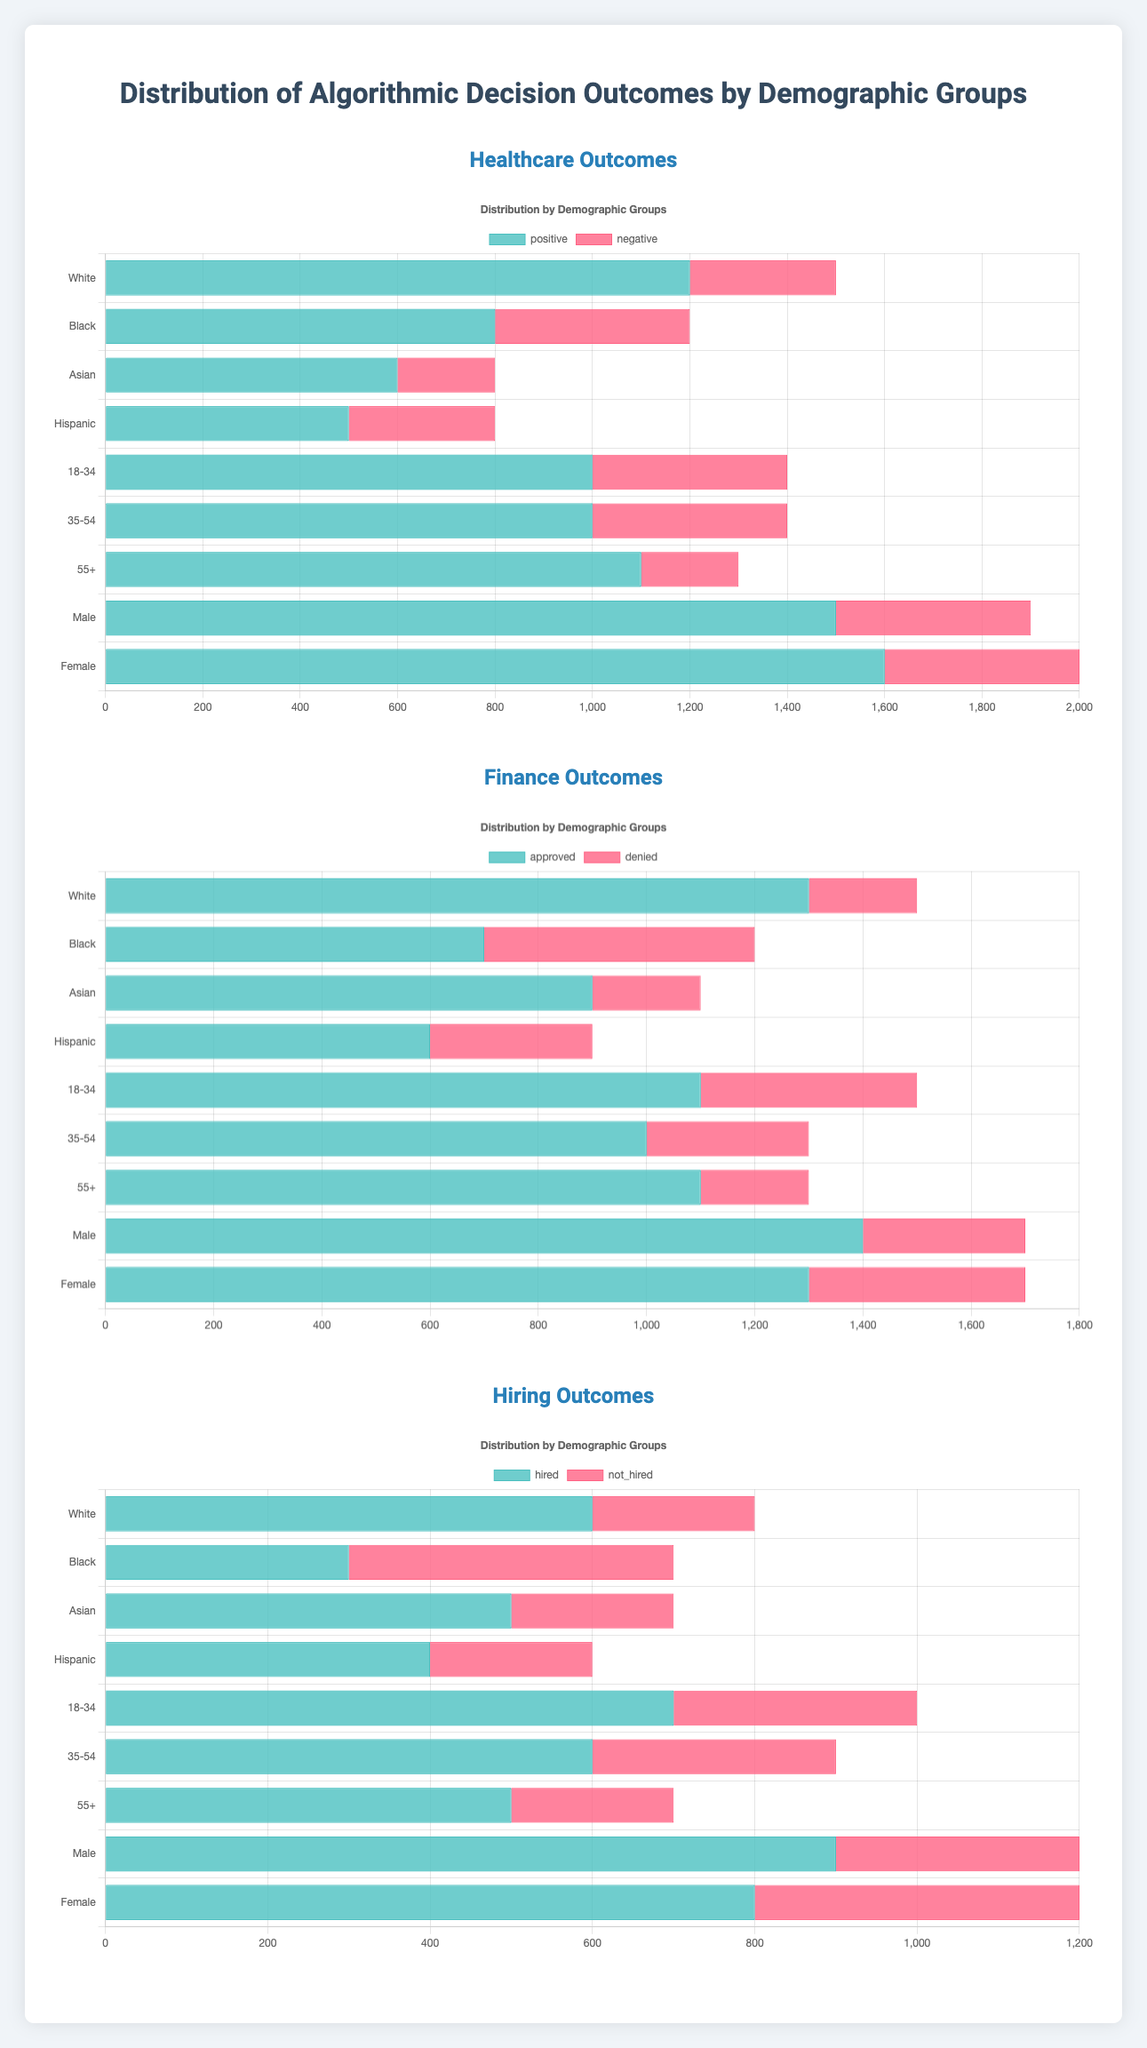How many more positive healthcare outcomes did White participants receive compared to Hispanic participants? First, locate the positive outcomes for both groups in the healthcare section of the chart. White participants received 1200 positive outcomes, while Hispanic participants received 500. The difference is 1200 - 500 = 700.
Answer: 700 Which gender had more negative outcomes in the finance sector? Review the negative outcomes for each gender in the finance section. Males have 300 negative outcomes, and Females have 400. Females had more negative outcomes.
Answer: Female Is the number of positive outcomes for healthcare gender groups higher than the number of positive outcomes for healthcare age groups? Sum the positive outcomes for the gender groups: Male (1500) + Female (1600) = 3100. Then sum the positive outcomes for age groups: 18-34 (1000) + 35-54 (1000) + 55+ (1100) = 3100. Both groups have the same number of positive outcomes.
Answer: No What is the combined number of approved finance outcomes for Asian and Hispanic groups? Add the approved outcomes for Asian and Hispanic groups: Asian (900) + Hispanic (600) = 1500.
Answer: 1500 Which age group has the smallest difference between positive and negative healthcare outcomes? Calculate the difference for each age group: 18-34 has 1000 - 400 = 600, 35-54 has 1000 - 400 = 600, 55+ has 1100 - 200 = 900. Both 18-34 and 35-54 age groups have the smallest difference of 600.
Answer: 18-34 and 35-54 What is the ratio of positive to negative healthcare outcomes for Black participants? Black participants have 800 positive and 400 negative outcomes. The ratio is 800:400, which simplifies to 2:1.
Answer: 2:1 Which racial group has the highest hiring rate? The hiring rate can be determined by comparing the hired counts for each racial group. White: 600, Black: 300, Asian: 500, Hispanic: 400. White group has the highest hiring count of 600.
Answer: White How does the number of denied finance applications compare between 18-34 and 35-54 age groups? The 18-34 age group has 400 denied applications and the 35-54 age group has 300 denied applications. 18-34 age group has more denied applications.
Answer: 18-34 What is the combined number of positive and negative outcomes in healthcare for Asian participants? Sum the positive and negative healthcare outcomes for Asians: 600 positive + 200 negative = 800 total outcomes.
Answer: 800 Which gender had a greater number of positive healthcare outcomes? Compare the positive healthcare outcomes for each gender. Males have 1500 positive outcomes and Females have 1600. Females had more positive healthcare outcomes.
Answer: Female 